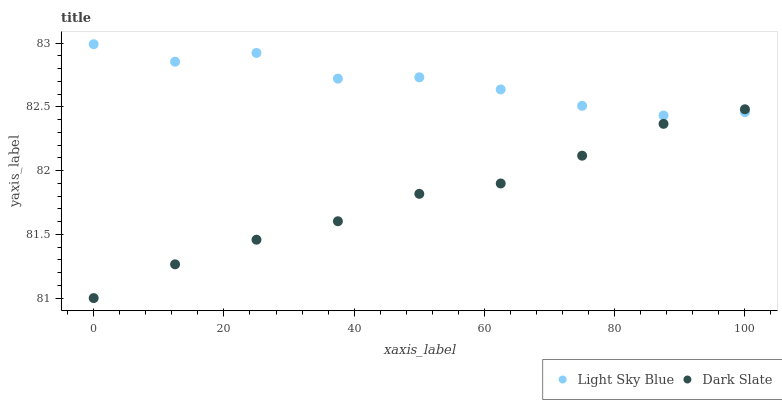Does Dark Slate have the minimum area under the curve?
Answer yes or no. Yes. Does Light Sky Blue have the maximum area under the curve?
Answer yes or no. Yes. Does Light Sky Blue have the minimum area under the curve?
Answer yes or no. No. Is Dark Slate the smoothest?
Answer yes or no. Yes. Is Light Sky Blue the roughest?
Answer yes or no. Yes. Is Light Sky Blue the smoothest?
Answer yes or no. No. Does Dark Slate have the lowest value?
Answer yes or no. Yes. Does Light Sky Blue have the lowest value?
Answer yes or no. No. Does Light Sky Blue have the highest value?
Answer yes or no. Yes. Does Dark Slate intersect Light Sky Blue?
Answer yes or no. Yes. Is Dark Slate less than Light Sky Blue?
Answer yes or no. No. Is Dark Slate greater than Light Sky Blue?
Answer yes or no. No. 